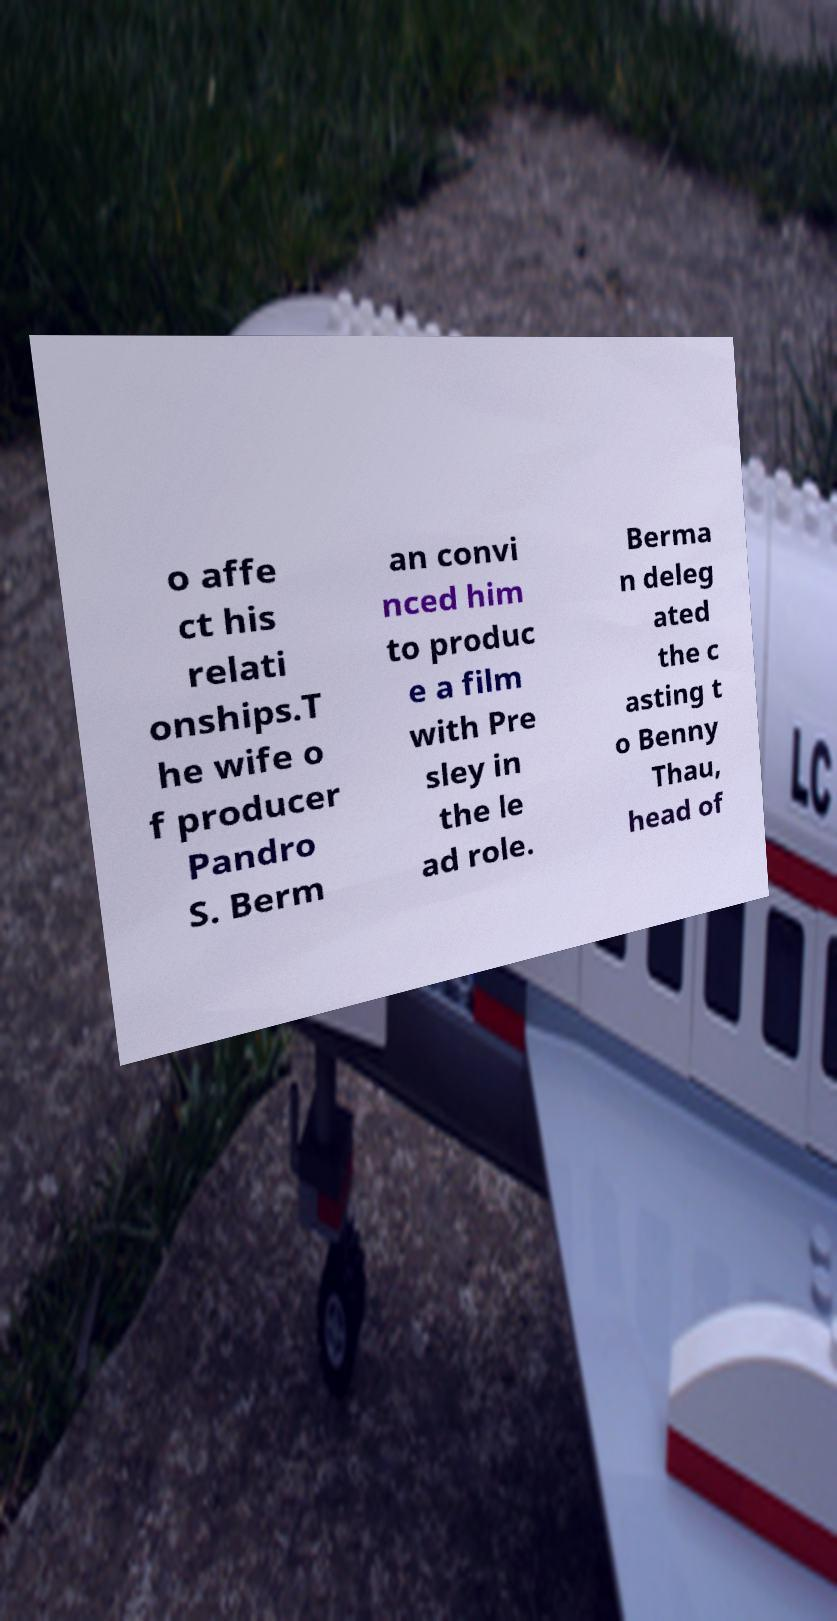Could you extract and type out the text from this image? o affe ct his relati onships.T he wife o f producer Pandro S. Berm an convi nced him to produc e a film with Pre sley in the le ad role. Berma n deleg ated the c asting t o Benny Thau, head of 